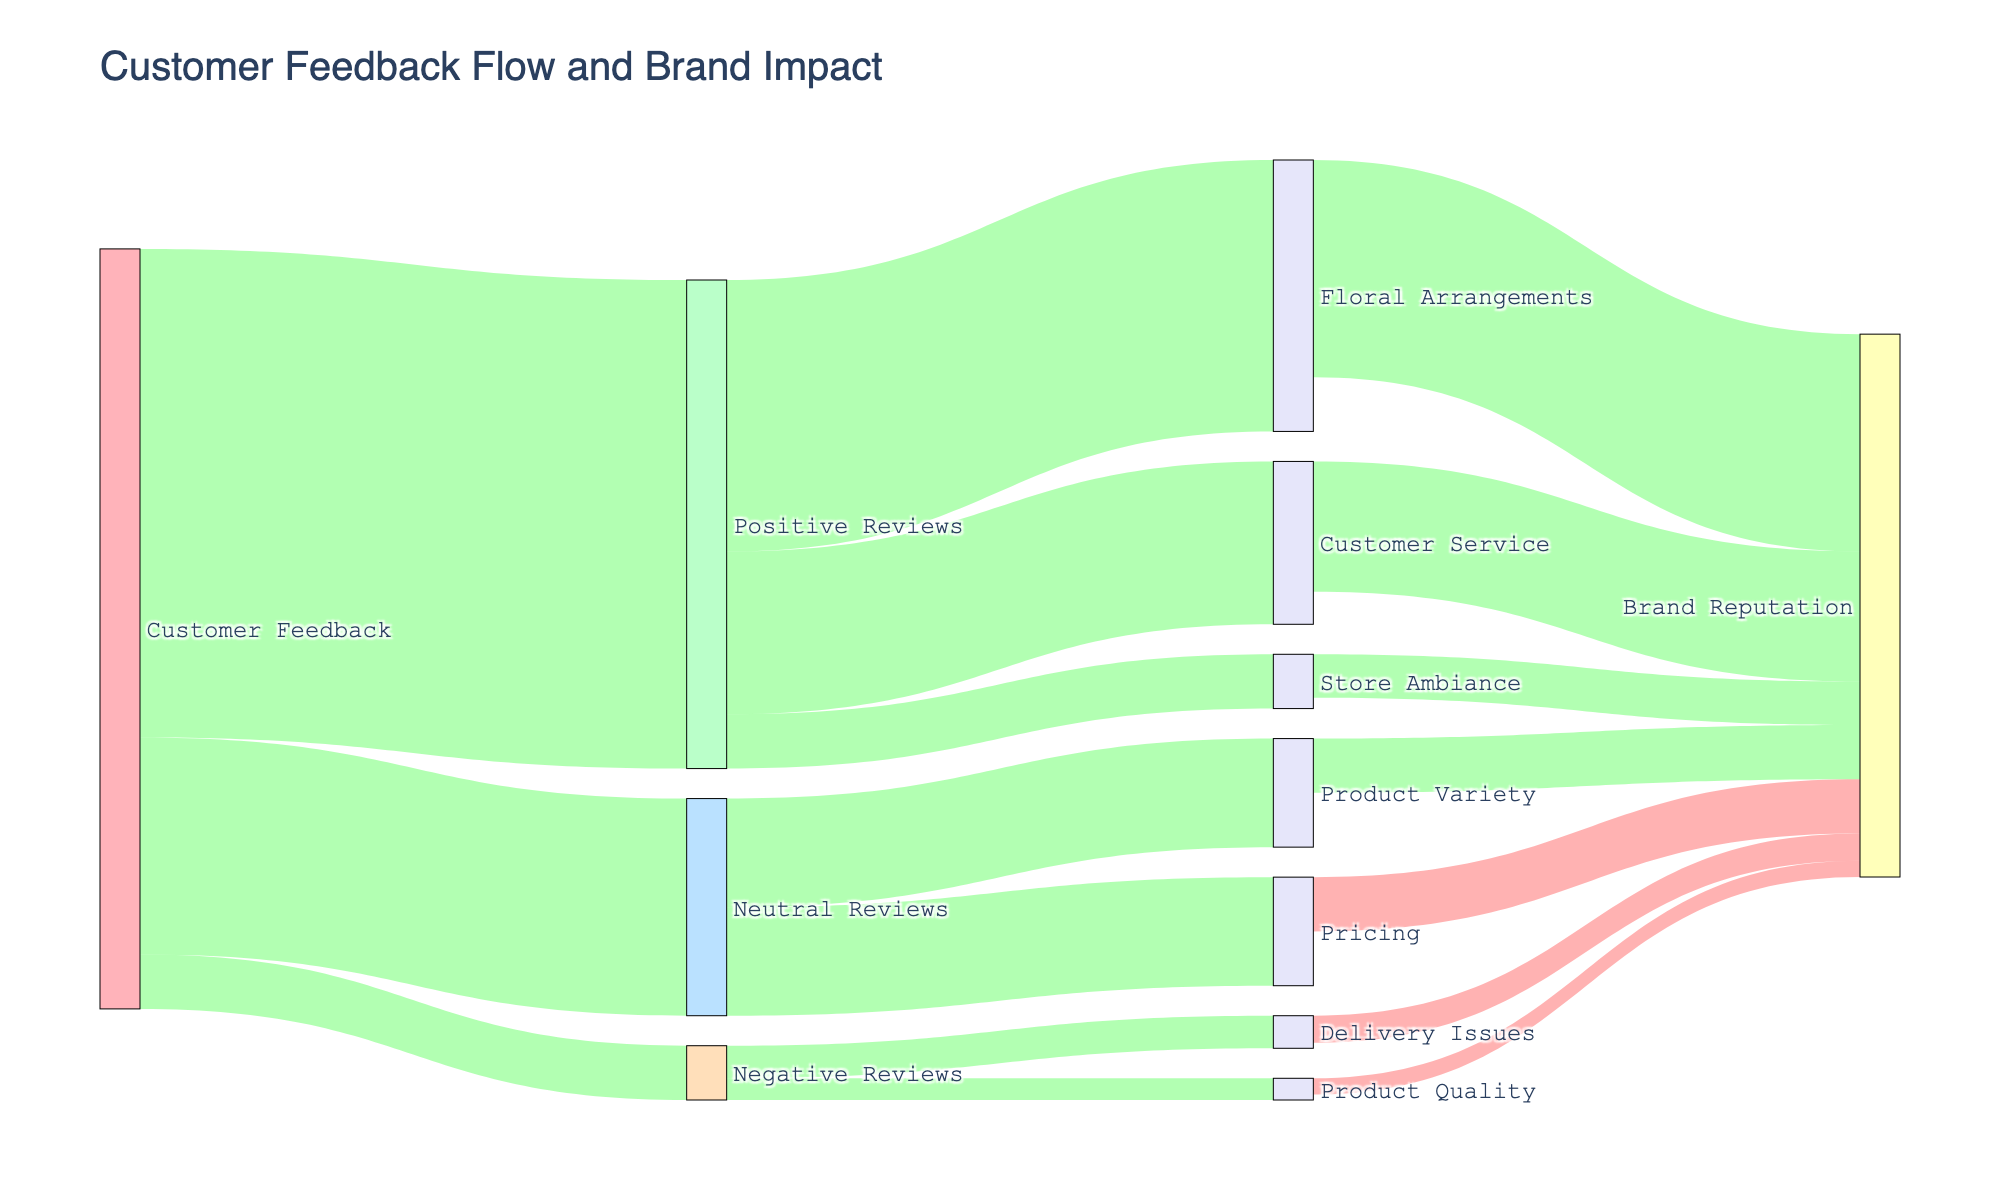what is the main topic of the figure? The title of the figure is "Customer Feedback Flow and Brand Impact," indicating that the figure visually represents how different categories of customer feedback affect brand reputation.
Answer: Customer Feedback Flow and Brand Impact Which feedback category has the highest number of reviews? The widest link emanating from "Customer Feedback" is towards "Positive Reviews," indicating it has the highest number with a value of 450.
Answer: Positive Reviews How do neutral reviews affect the brand reputation? Neutral reviews split into two categories: Pricing and Product Variety. Pricing has a negative impact with a value of -50, while Product Variety has a positive impact with a value of 50.
Answer: Neutral reviews cancel each other out on brand reputation What category gained the most positive reviews? The widest link from "Positive Reviews" is towards "Floral Arrangements" with a value of 250.
Answer: Floral Arrangements Which aspect has the most negative impact on brand reputation? The link from "Pricing" to "Brand Reputation" is the most negative, showing a value of -50.
Answer: Pricing Which aspect of negative reviews impacts brand reputation least? The link from "Product Quality" to "Brand Reputation" is the smallest negative impact with a value of -15.
Answer: Product Quality What is the total value of positive impacts on brand reputation? Add the values of "Floral Arrangements" (200), "Customer Service" (120), and "Store Ambiance" (40), which sum up to 360.
Answer: 360 How do customer service and store ambiance compare in terms of positive reviews? The link from "Positive Reviews" to "Customer Service" is wider (150) compared to "Store Ambiance" (50), indicating "Customer Service" has more positive reviews.
Answer: Customer Service has more positive reviews Which specific issues in negative reviews have been identified in the figure? Two specific issues are identified under "Negative Reviews": "Delivery Issues" (30) and "Product Quality" (20).
Answer: Delivery Issues and Product Quality What is the overall impact of customer feedback categories on brand reputation? Positive impacts: 200 (Floral Arrangements) + 120 (Customer Service) + 40 (Store Ambiance) + 50 (Product Variety) = 410. Negative impacts: -50 (Pricing) - 25 (Delivery Issues) - 15 (Product Quality) = -90. The net impact is 410 - 90 = 320.
Answer: 320 (Net Positive) 